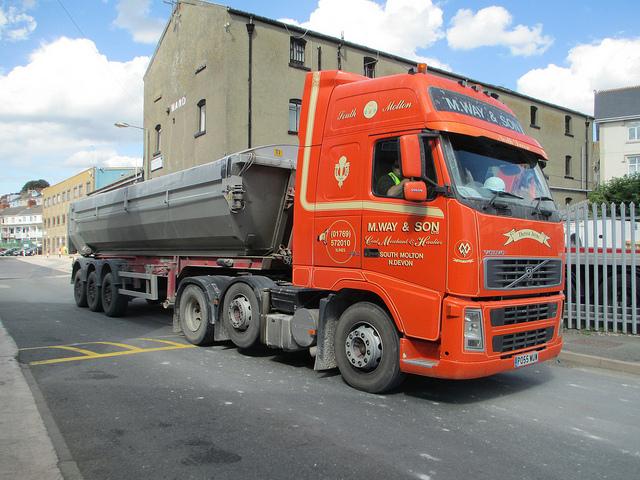What color is the hard hat?
Quick response, please. White. Is the writing on the truck in English?
Keep it brief. Yes. What color truck is it?
Answer briefly. Orange. Is it snowing?
Keep it brief. No. 